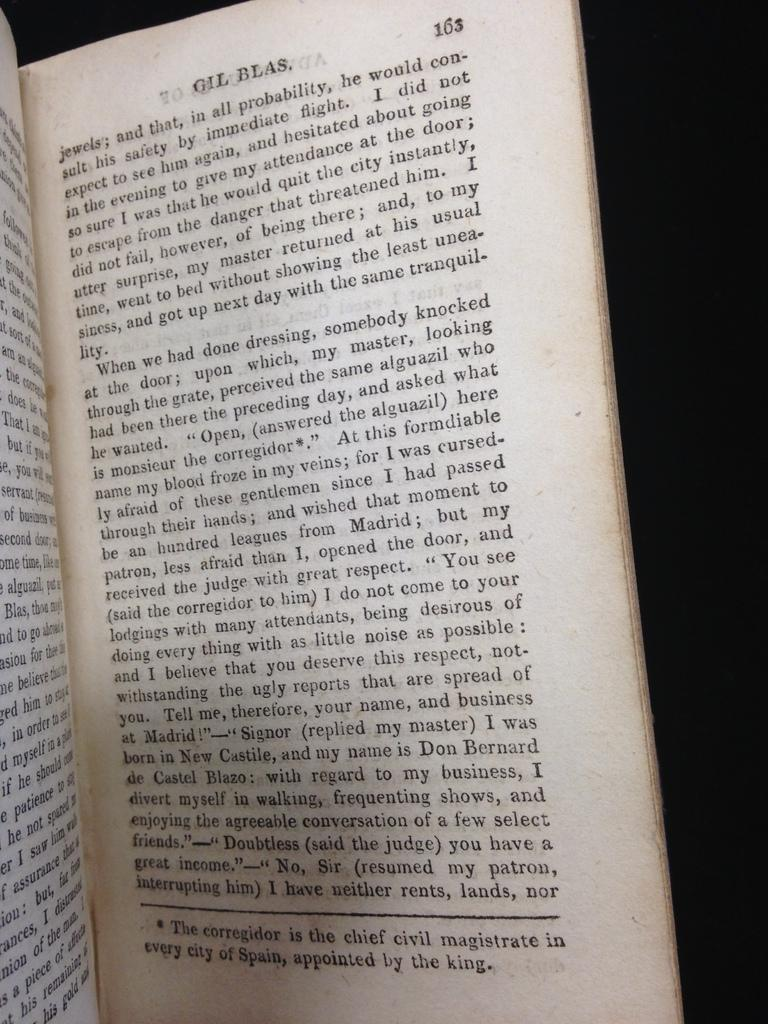What is the main subject in the center of the image? There is a book in the center of the image. What can be seen on the book? There is writing on the book. How fast is the book running in the image? The book is not running in the image; it is stationary. What is the rating of the book in the image? There is no rating visible on the book in the image. 